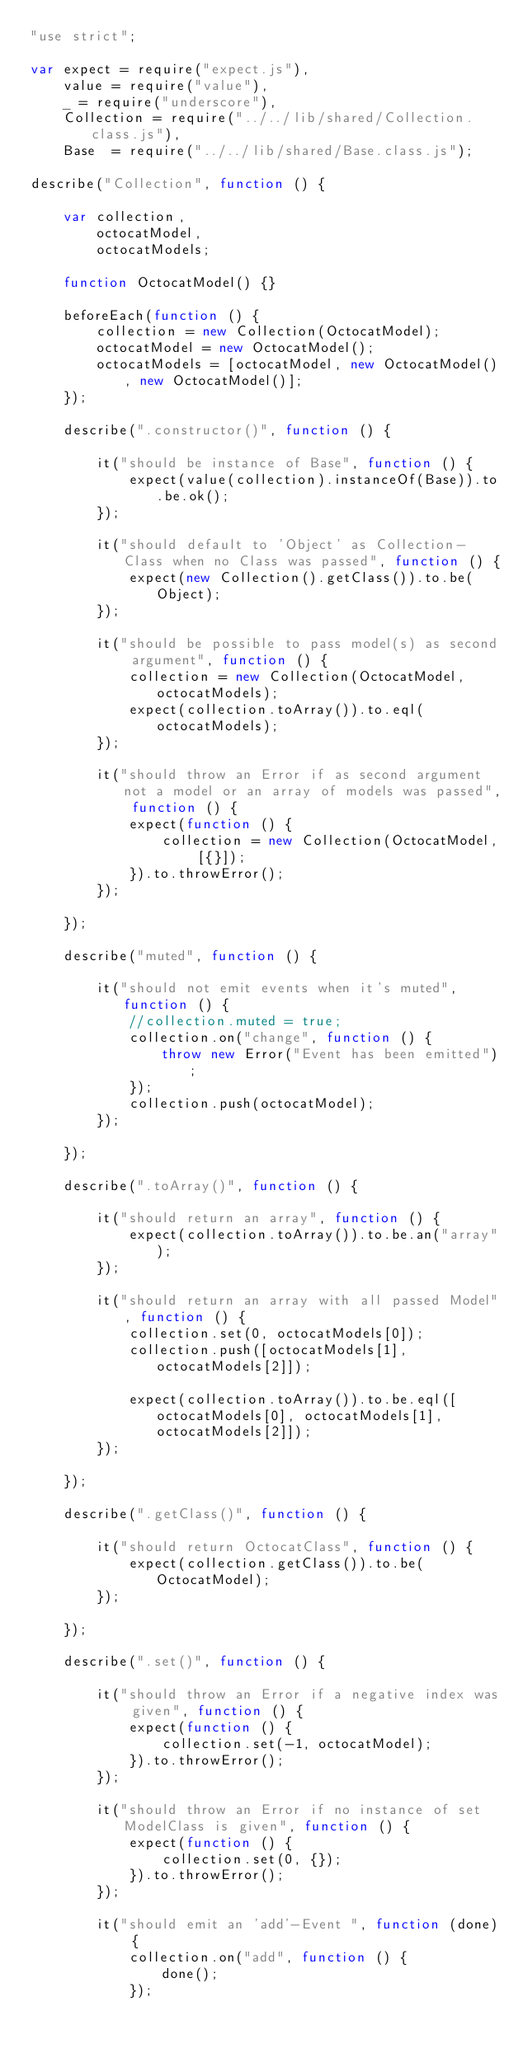<code> <loc_0><loc_0><loc_500><loc_500><_JavaScript_>"use strict";

var expect = require("expect.js"),
    value = require("value"),
    _ = require("underscore"),
    Collection = require("../../lib/shared/Collection.class.js"),
    Base  = require("../../lib/shared/Base.class.js");

describe("Collection", function () {

    var collection,
        octocatModel,
        octocatModels;

    function OctocatModel() {}

    beforeEach(function () {
        collection = new Collection(OctocatModel);
        octocatModel = new OctocatModel();
        octocatModels = [octocatModel, new OctocatModel(), new OctocatModel()];
    });

    describe(".constructor()", function () {

        it("should be instance of Base", function () {
            expect(value(collection).instanceOf(Base)).to.be.ok();
        });

        it("should default to 'Object' as Collection-Class when no Class was passed", function () {
            expect(new Collection().getClass()).to.be(Object);
        });

        it("should be possible to pass model(s) as second argument", function () {
            collection = new Collection(OctocatModel, octocatModels);
            expect(collection.toArray()).to.eql(octocatModels);
        });

        it("should throw an Error if as second argument not a model or an array of models was passed", function () {
            expect(function () {
                collection = new Collection(OctocatModel, [{}]);
            }).to.throwError();
        });

    });

    describe("muted", function () {

        it("should not emit events when it's muted", function () {
            //collection.muted = true;
            collection.on("change", function () {
                throw new Error("Event has been emitted");
            });
            collection.push(octocatModel);
        });

    });

    describe(".toArray()", function () {

        it("should return an array", function () {
            expect(collection.toArray()).to.be.an("array");
        });

        it("should return an array with all passed Model", function () {
            collection.set(0, octocatModels[0]);
            collection.push([octocatModels[1], octocatModels[2]]);

            expect(collection.toArray()).to.be.eql([octocatModels[0], octocatModels[1], octocatModels[2]]);
        });

    });

    describe(".getClass()", function () {

        it("should return OctocatClass", function () {
            expect(collection.getClass()).to.be(OctocatModel);
        });

    });

    describe(".set()", function () {

        it("should throw an Error if a negative index was given", function () {
            expect(function () {
                collection.set(-1, octocatModel);
            }).to.throwError();
        });

        it("should throw an Error if no instance of set ModelClass is given", function () {
            expect(function () {
                collection.set(0, {});
            }).to.throwError();
        });

        it("should emit an 'add'-Event ", function (done) {
            collection.on("add", function () {
                done();
            });</code> 